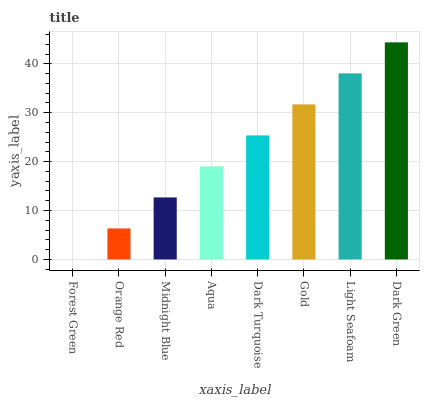Is Forest Green the minimum?
Answer yes or no. Yes. Is Dark Green the maximum?
Answer yes or no. Yes. Is Orange Red the minimum?
Answer yes or no. No. Is Orange Red the maximum?
Answer yes or no. No. Is Orange Red greater than Forest Green?
Answer yes or no. Yes. Is Forest Green less than Orange Red?
Answer yes or no. Yes. Is Forest Green greater than Orange Red?
Answer yes or no. No. Is Orange Red less than Forest Green?
Answer yes or no. No. Is Dark Turquoise the high median?
Answer yes or no. Yes. Is Aqua the low median?
Answer yes or no. Yes. Is Midnight Blue the high median?
Answer yes or no. No. Is Dark Turquoise the low median?
Answer yes or no. No. 